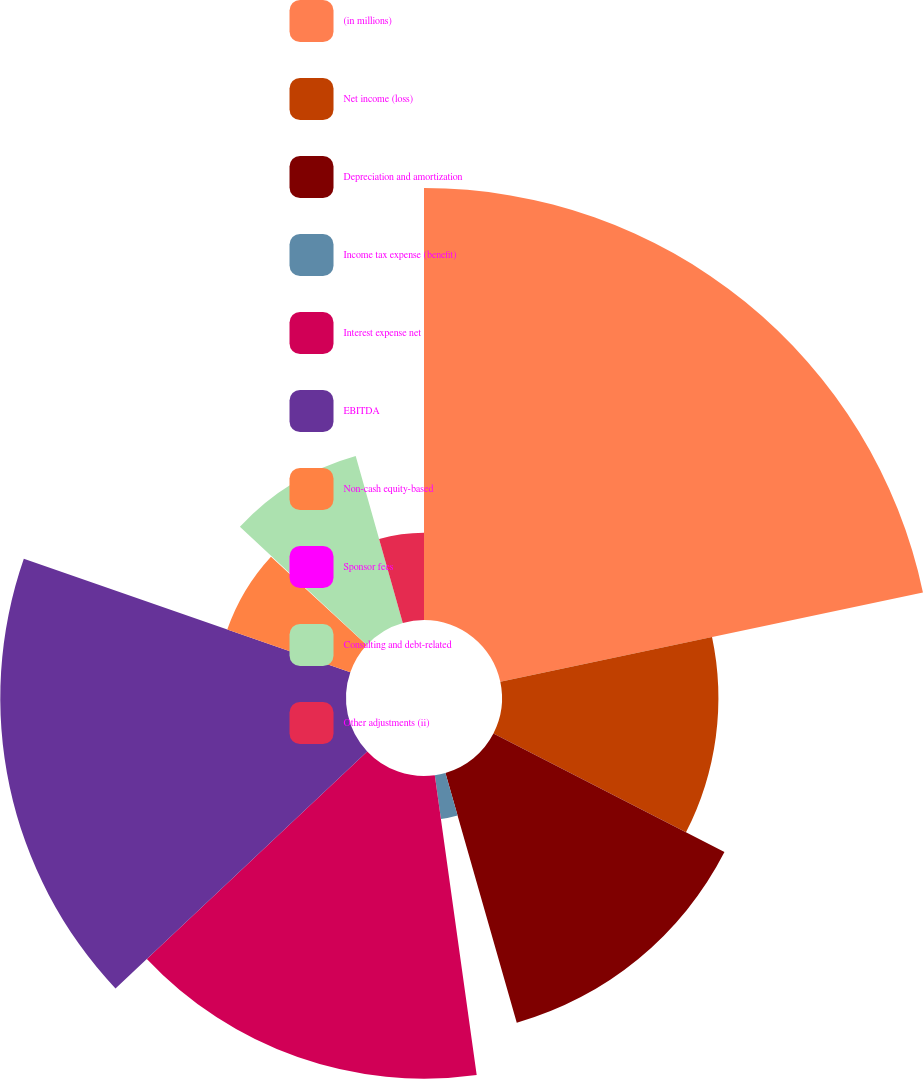<chart> <loc_0><loc_0><loc_500><loc_500><pie_chart><fcel>(in millions)<fcel>Net income (loss)<fcel>Depreciation and amortization<fcel>Income tax expense (benefit)<fcel>Interest expense net<fcel>EBITDA<fcel>Non-cash equity-based<fcel>Sponsor fees<fcel>Consulting and debt-related<fcel>Other adjustments (ii)<nl><fcel>21.68%<fcel>10.86%<fcel>13.03%<fcel>2.22%<fcel>15.19%<fcel>17.35%<fcel>6.54%<fcel>0.05%<fcel>8.7%<fcel>4.38%<nl></chart> 